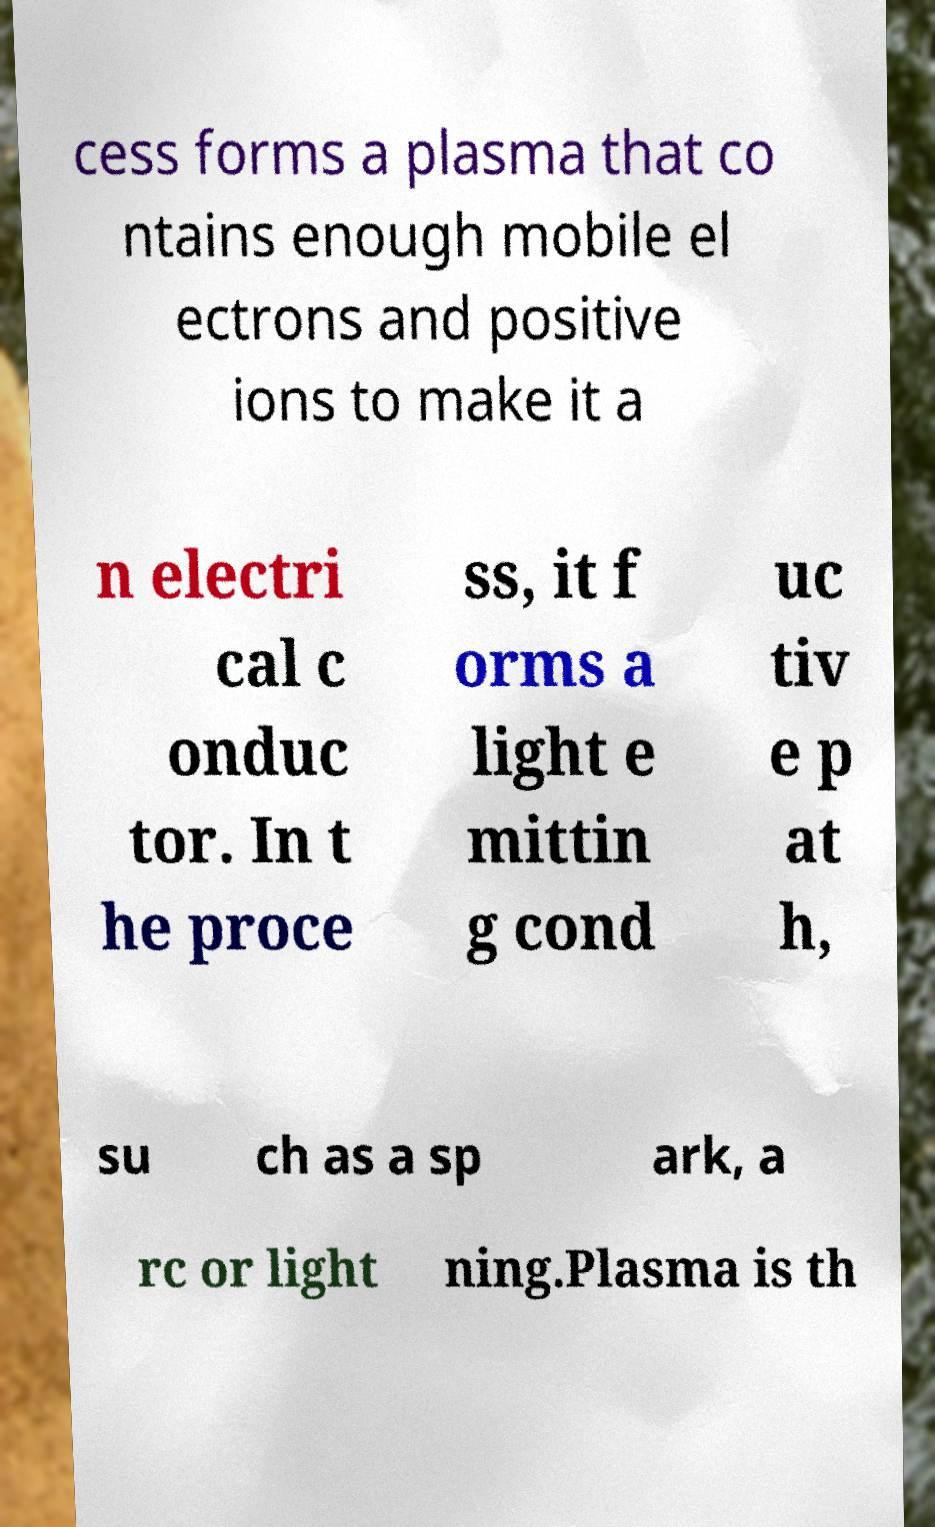There's text embedded in this image that I need extracted. Can you transcribe it verbatim? cess forms a plasma that co ntains enough mobile el ectrons and positive ions to make it a n electri cal c onduc tor. In t he proce ss, it f orms a light e mittin g cond uc tiv e p at h, su ch as a sp ark, a rc or light ning.Plasma is th 